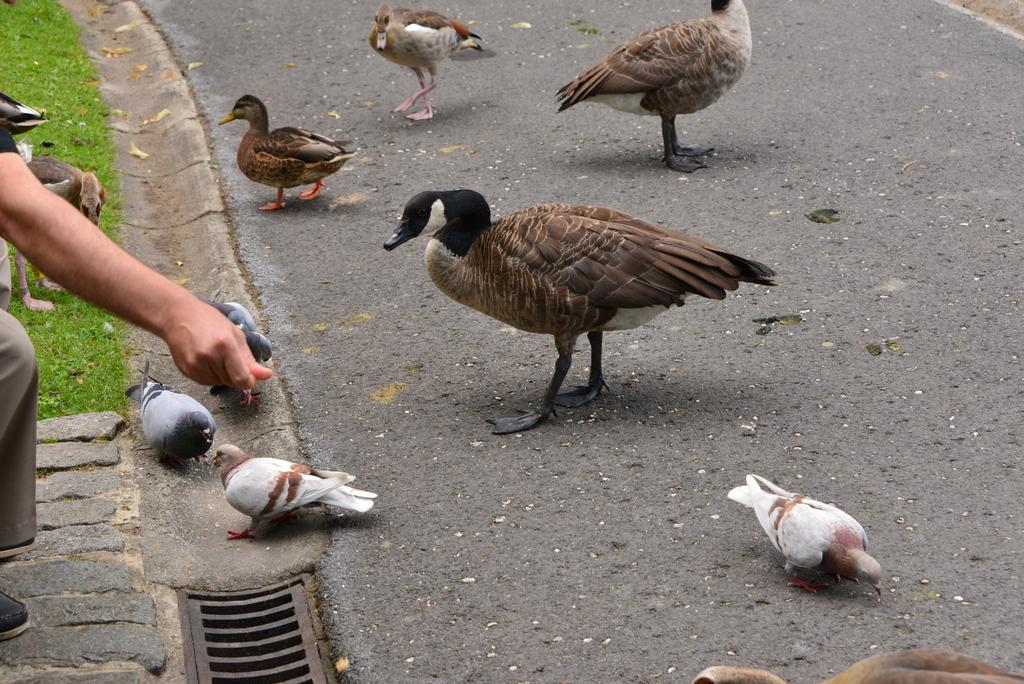What is present on the road in the image? There is a group of birds on the road in the image. What can be seen on the left side of the image? There is a hand of a person and a grill on the left side of the image. What type of vegetation is visible in the image? There is grass visible in the image. How many rings are being used to support the cable in the image? There are no rings or cables present in the image. What type of support is provided by the rings for the cable in the image? Since there are no rings or cables in the image, this question cannot be answered. 